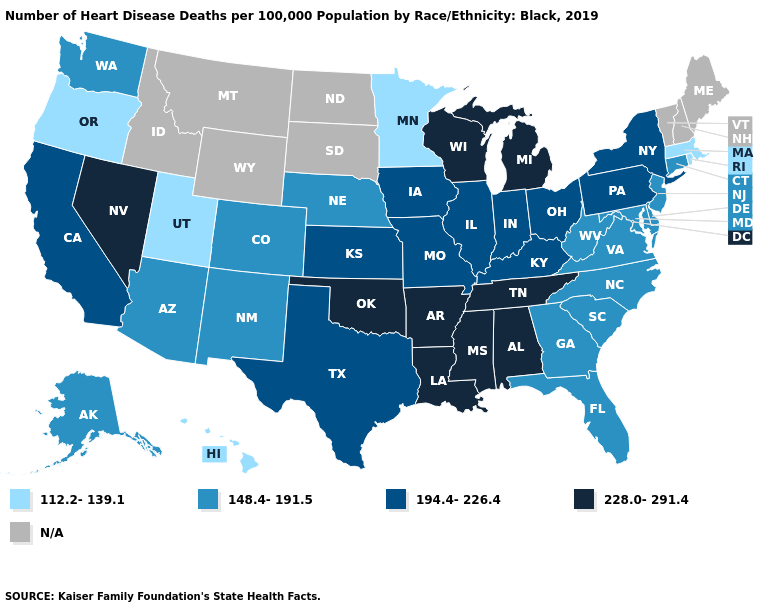What is the value of Washington?
Write a very short answer. 148.4-191.5. Name the states that have a value in the range 194.4-226.4?
Give a very brief answer. California, Illinois, Indiana, Iowa, Kansas, Kentucky, Missouri, New York, Ohio, Pennsylvania, Texas. Does North Carolina have the highest value in the South?
Concise answer only. No. What is the value of New York?
Keep it brief. 194.4-226.4. What is the value of Missouri?
Quick response, please. 194.4-226.4. Which states have the lowest value in the West?
Answer briefly. Hawaii, Oregon, Utah. Which states have the highest value in the USA?
Write a very short answer. Alabama, Arkansas, Louisiana, Michigan, Mississippi, Nevada, Oklahoma, Tennessee, Wisconsin. Among the states that border Missouri , which have the highest value?
Give a very brief answer. Arkansas, Oklahoma, Tennessee. Which states have the highest value in the USA?
Answer briefly. Alabama, Arkansas, Louisiana, Michigan, Mississippi, Nevada, Oklahoma, Tennessee, Wisconsin. What is the lowest value in the USA?
Short answer required. 112.2-139.1. What is the lowest value in the West?
Concise answer only. 112.2-139.1. What is the lowest value in the MidWest?
Keep it brief. 112.2-139.1. Among the states that border Nebraska , does Missouri have the lowest value?
Answer briefly. No. What is the value of Missouri?
Write a very short answer. 194.4-226.4. Does Oregon have the lowest value in the West?
Give a very brief answer. Yes. 